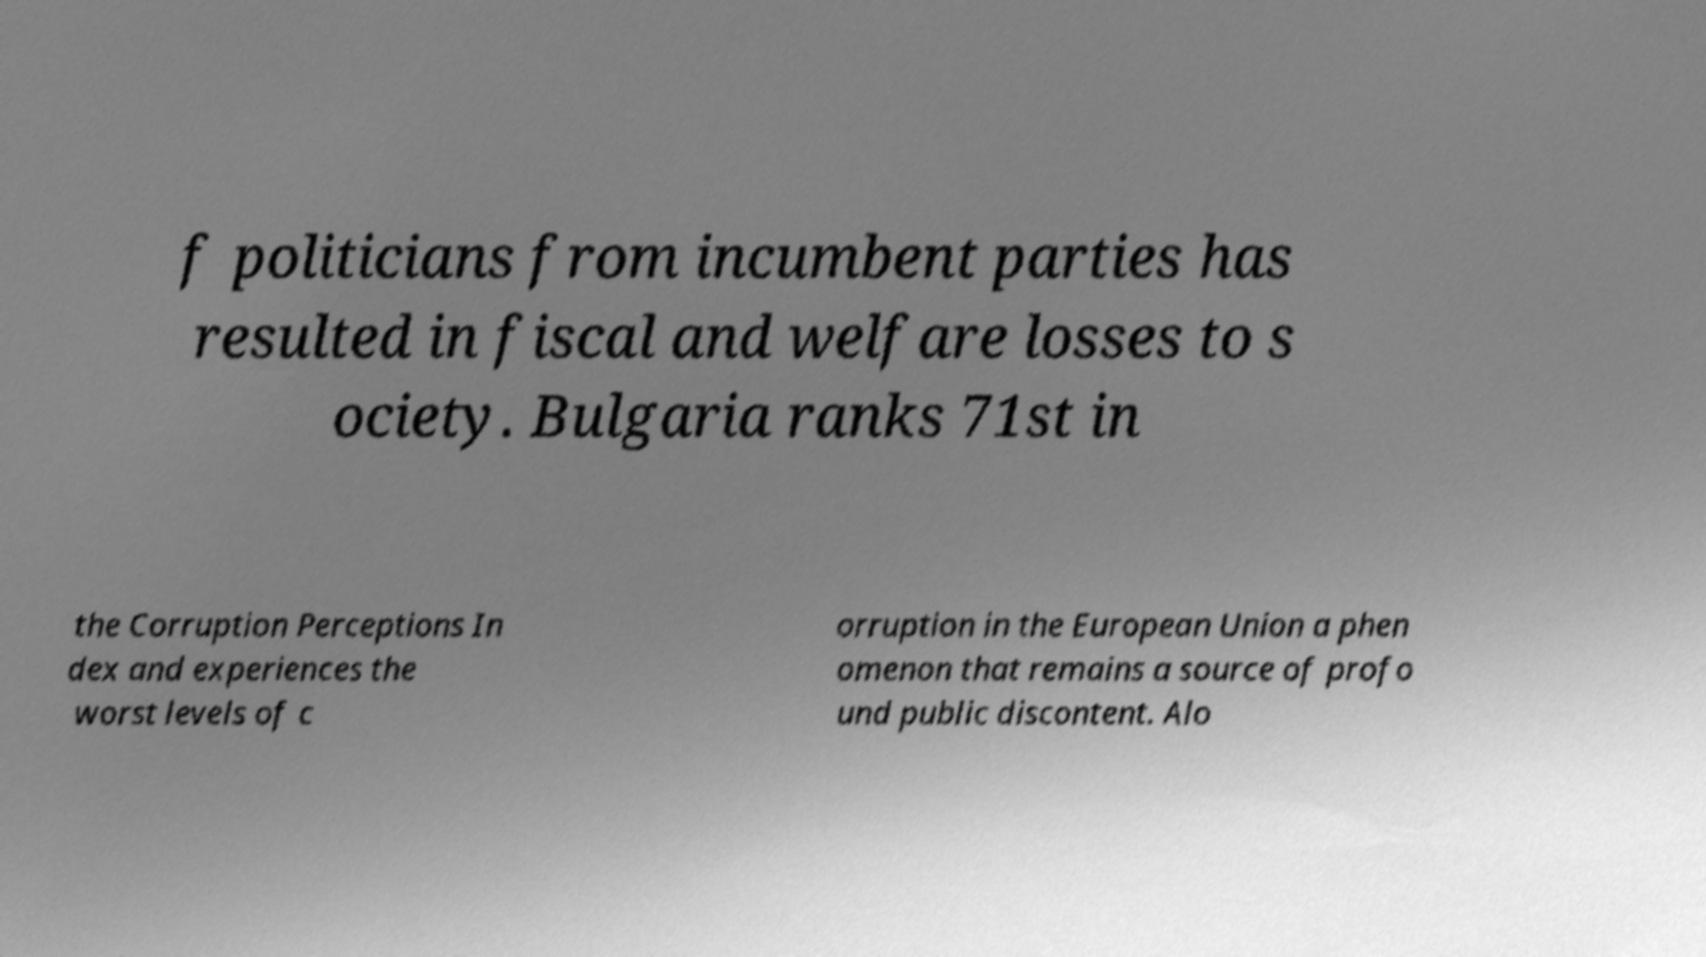Can you read and provide the text displayed in the image?This photo seems to have some interesting text. Can you extract and type it out for me? f politicians from incumbent parties has resulted in fiscal and welfare losses to s ociety. Bulgaria ranks 71st in the Corruption Perceptions In dex and experiences the worst levels of c orruption in the European Union a phen omenon that remains a source of profo und public discontent. Alo 